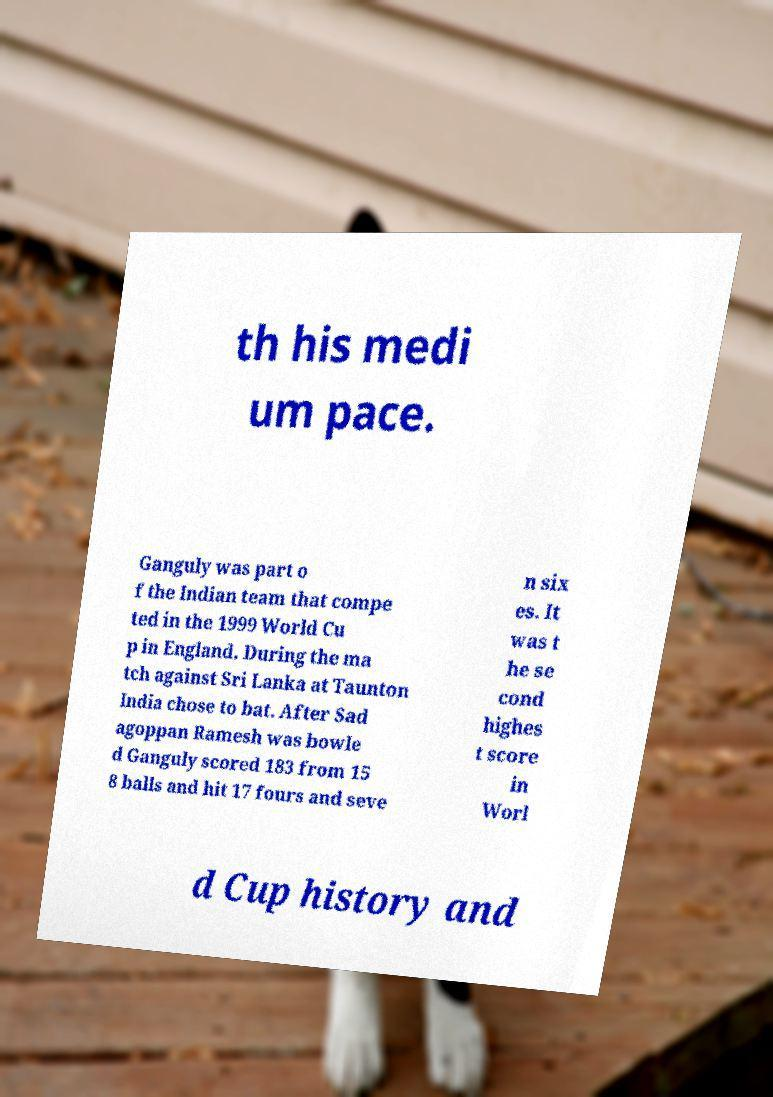Please read and relay the text visible in this image. What does it say? th his medi um pace. Ganguly was part o f the Indian team that compe ted in the 1999 World Cu p in England. During the ma tch against Sri Lanka at Taunton India chose to bat. After Sad agoppan Ramesh was bowle d Ganguly scored 183 from 15 8 balls and hit 17 fours and seve n six es. It was t he se cond highes t score in Worl d Cup history and 